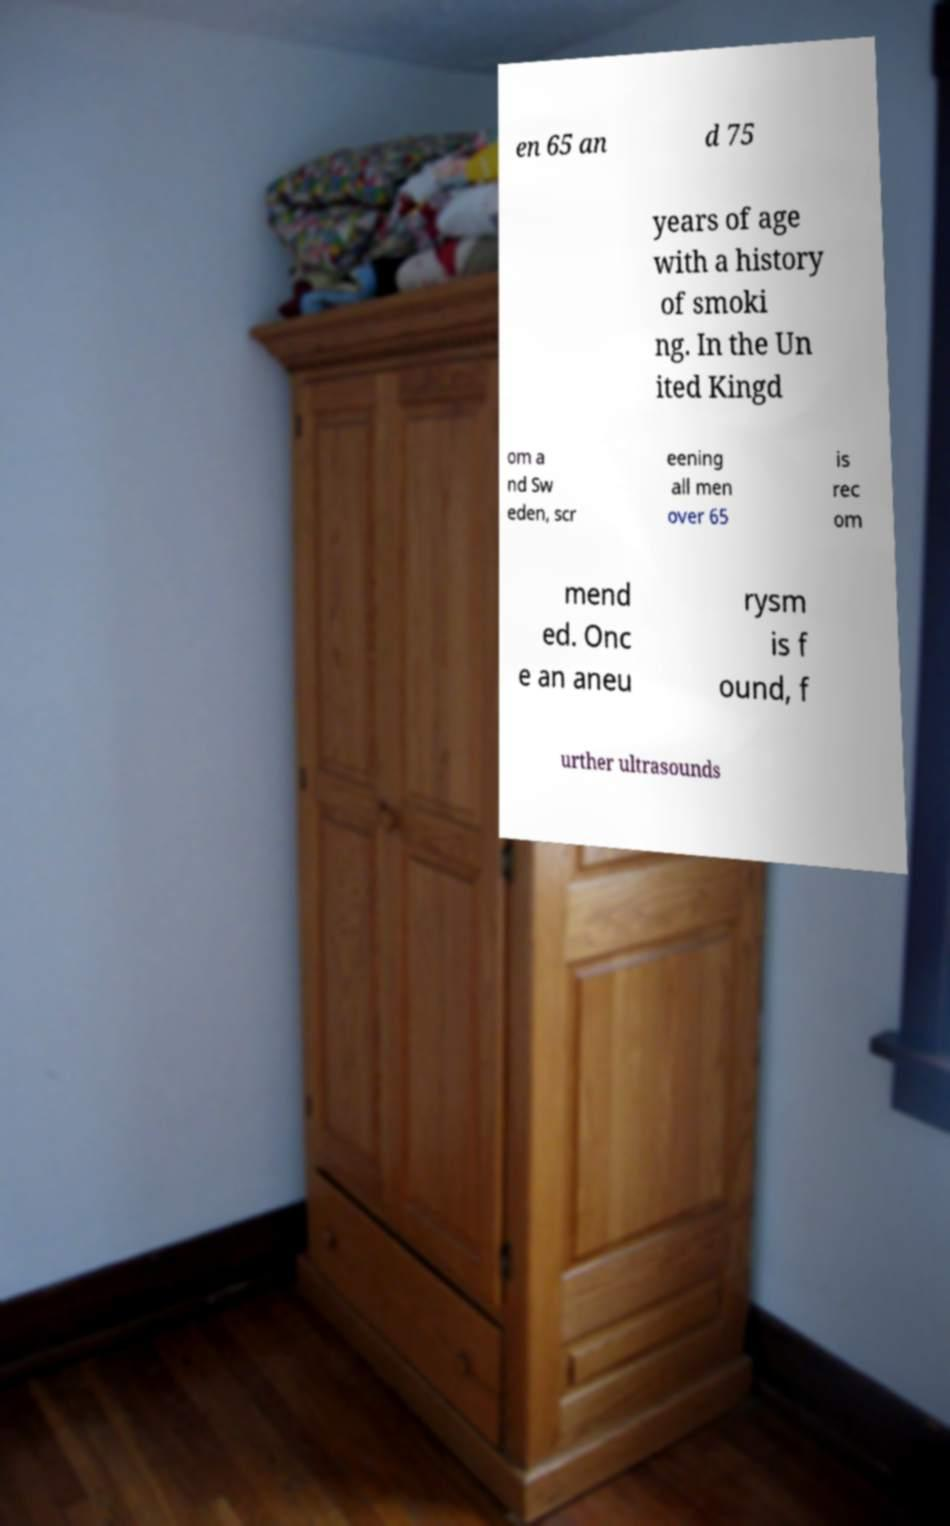There's text embedded in this image that I need extracted. Can you transcribe it verbatim? en 65 an d 75 years of age with a history of smoki ng. In the Un ited Kingd om a nd Sw eden, scr eening all men over 65 is rec om mend ed. Onc e an aneu rysm is f ound, f urther ultrasounds 